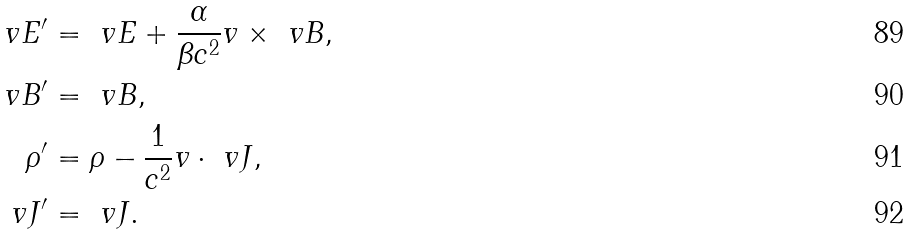<formula> <loc_0><loc_0><loc_500><loc_500>\ v E ^ { \prime } & = \ v E + \frac { \alpha } { \beta c ^ { 2 } } v \times \ v B , \\ \ v B ^ { \prime } & = \ v B , \\ \rho ^ { \prime } & = \rho - \frac { 1 } { c ^ { 2 } } v \cdot \ v J , \\ \ v J ^ { \prime } & = \ v J .</formula> 